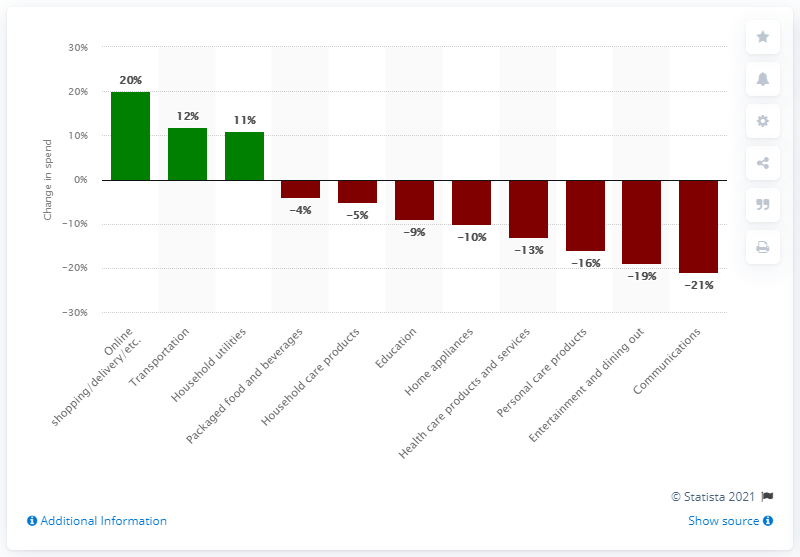Draw attention to some important aspects in this diagram. Online shopping and delivery services have significantly contributed to an increase in consumer spending of 20%. 